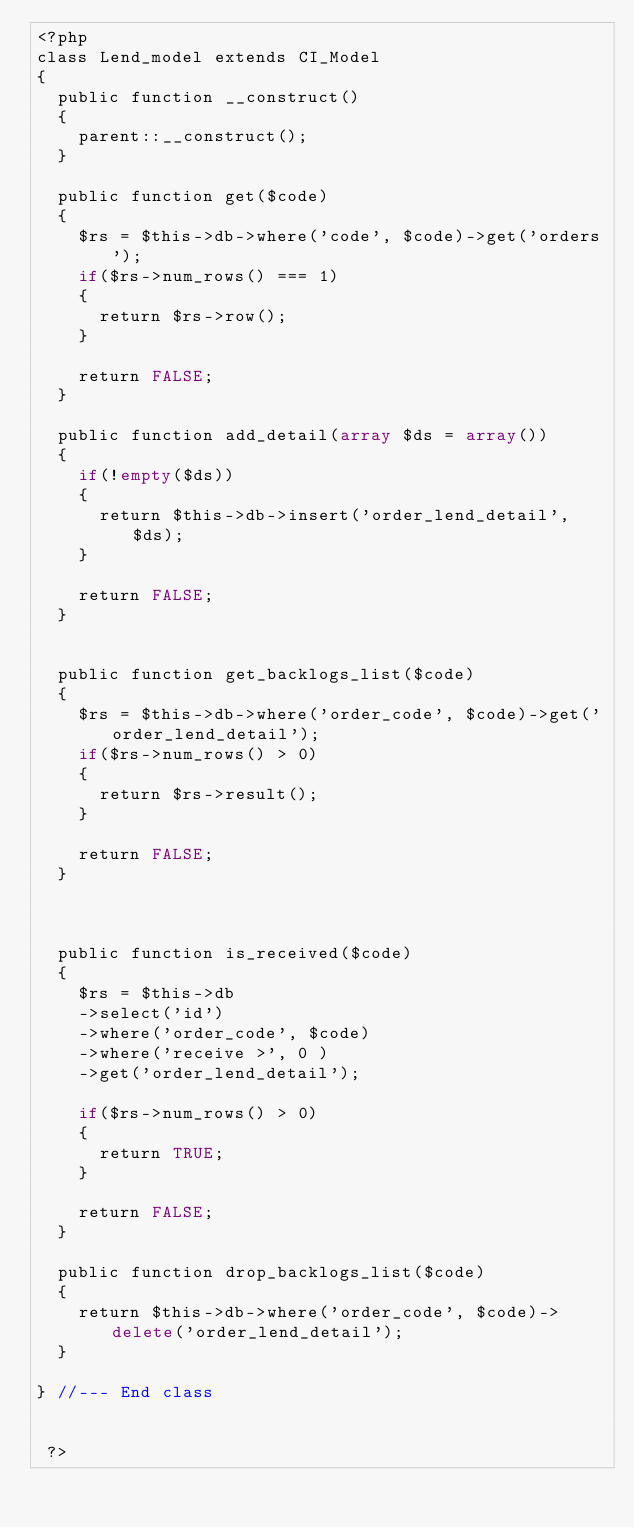<code> <loc_0><loc_0><loc_500><loc_500><_PHP_><?php
class Lend_model extends CI_Model
{
  public function __construct()
  {
    parent::__construct();
  }

  public function get($code)
  {
    $rs = $this->db->where('code', $code)->get('orders');
    if($rs->num_rows() === 1)
    {
      return $rs->row();
    }

    return FALSE;
  }

  public function add_detail(array $ds = array())
  {
    if(!empty($ds))
    {
      return $this->db->insert('order_lend_detail', $ds);
    }

    return FALSE;
  }


  public function get_backlogs_list($code)
  {
    $rs = $this->db->where('order_code', $code)->get('order_lend_detail');
    if($rs->num_rows() > 0)
    {
      return $rs->result();
    }

    return FALSE;
  }



  public function is_received($code)
  {
    $rs = $this->db
    ->select('id')
    ->where('order_code', $code)
    ->where('receive >', 0 )
    ->get('order_lend_detail');

    if($rs->num_rows() > 0)
    {
      return TRUE;
    }

    return FALSE;
  }

  public function drop_backlogs_list($code)
  {
    return $this->db->where('order_code', $code)->delete('order_lend_detail');
  }

} //--- End class


 ?>
</code> 